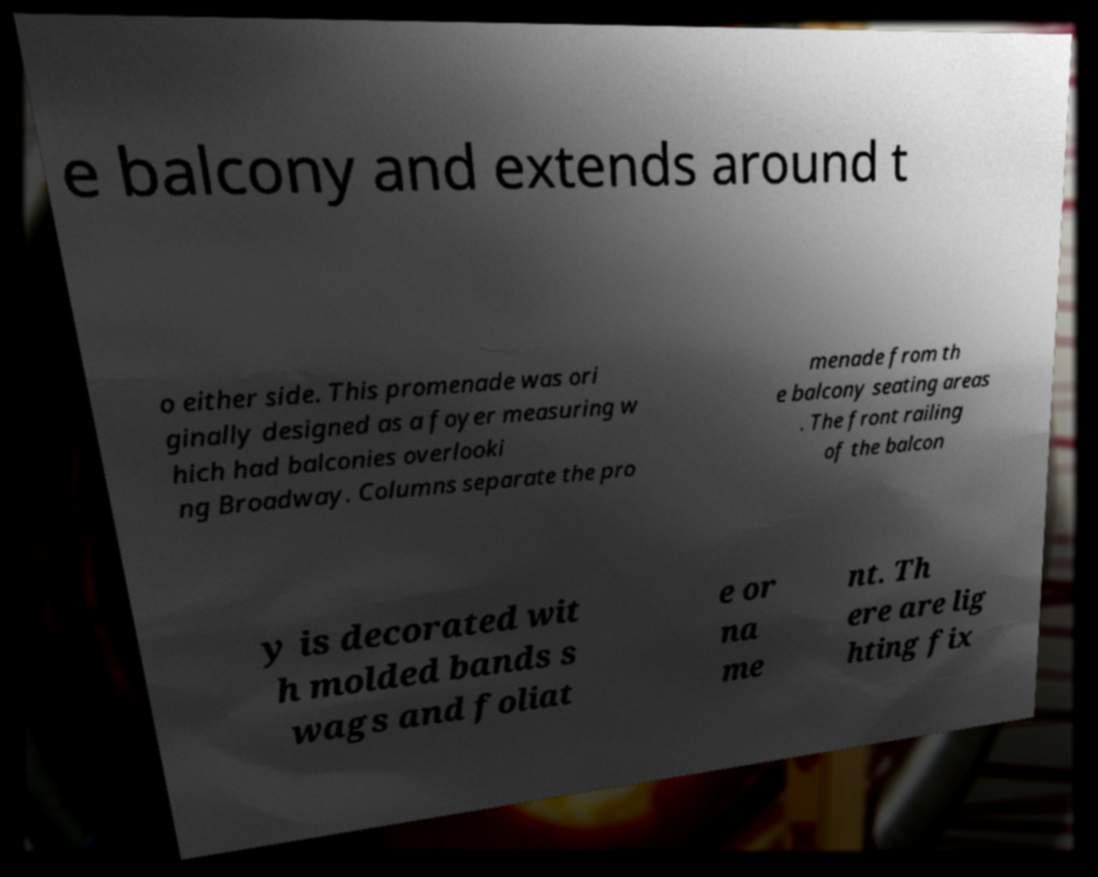What messages or text are displayed in this image? I need them in a readable, typed format. e balcony and extends around t o either side. This promenade was ori ginally designed as a foyer measuring w hich had balconies overlooki ng Broadway. Columns separate the pro menade from th e balcony seating areas . The front railing of the balcon y is decorated wit h molded bands s wags and foliat e or na me nt. Th ere are lig hting fix 